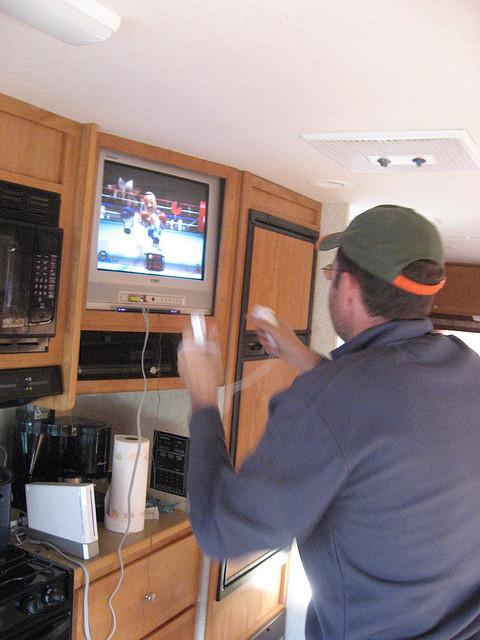What kind of show is this man watching?
Give a very brief answer. Boxing. What color is the cabinet?
Be succinct. Brown. Is the man playing Nintendo?
Give a very brief answer. Yes. 